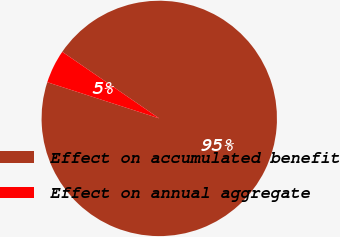<chart> <loc_0><loc_0><loc_500><loc_500><pie_chart><fcel>Effect on accumulated benefit<fcel>Effect on annual aggregate<nl><fcel>95.4%<fcel>4.6%<nl></chart> 